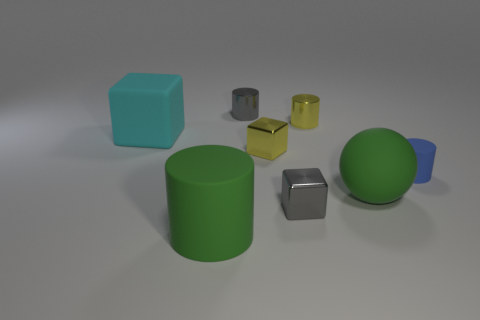Add 1 small gray cubes. How many objects exist? 9 Subtract all big matte cylinders. How many cylinders are left? 3 Subtract all brown cylinders. Subtract all blue spheres. How many cylinders are left? 4 Subtract all cubes. How many objects are left? 5 Add 5 green spheres. How many green spheres are left? 6 Add 2 big shiny blocks. How many big shiny blocks exist? 2 Subtract 1 gray cylinders. How many objects are left? 7 Subtract all small cylinders. Subtract all big gray shiny objects. How many objects are left? 5 